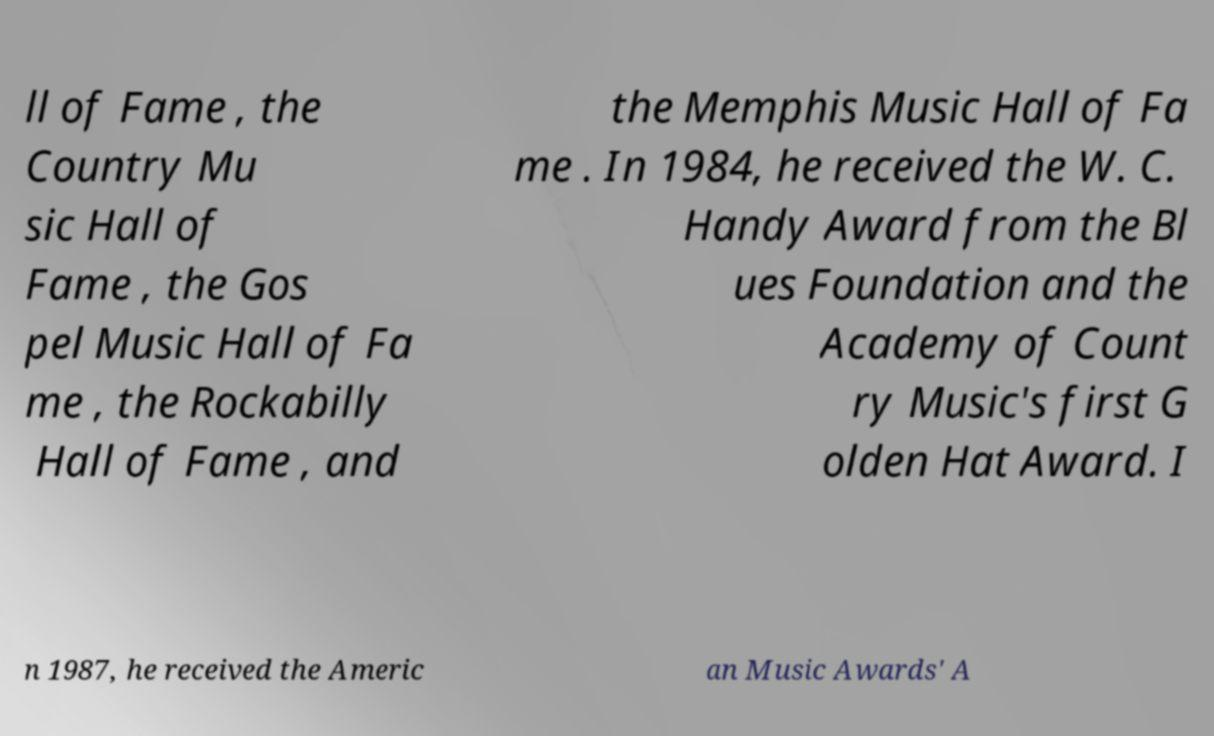Could you extract and type out the text from this image? ll of Fame , the Country Mu sic Hall of Fame , the Gos pel Music Hall of Fa me , the Rockabilly Hall of Fame , and the Memphis Music Hall of Fa me . In 1984, he received the W. C. Handy Award from the Bl ues Foundation and the Academy of Count ry Music's first G olden Hat Award. I n 1987, he received the Americ an Music Awards' A 